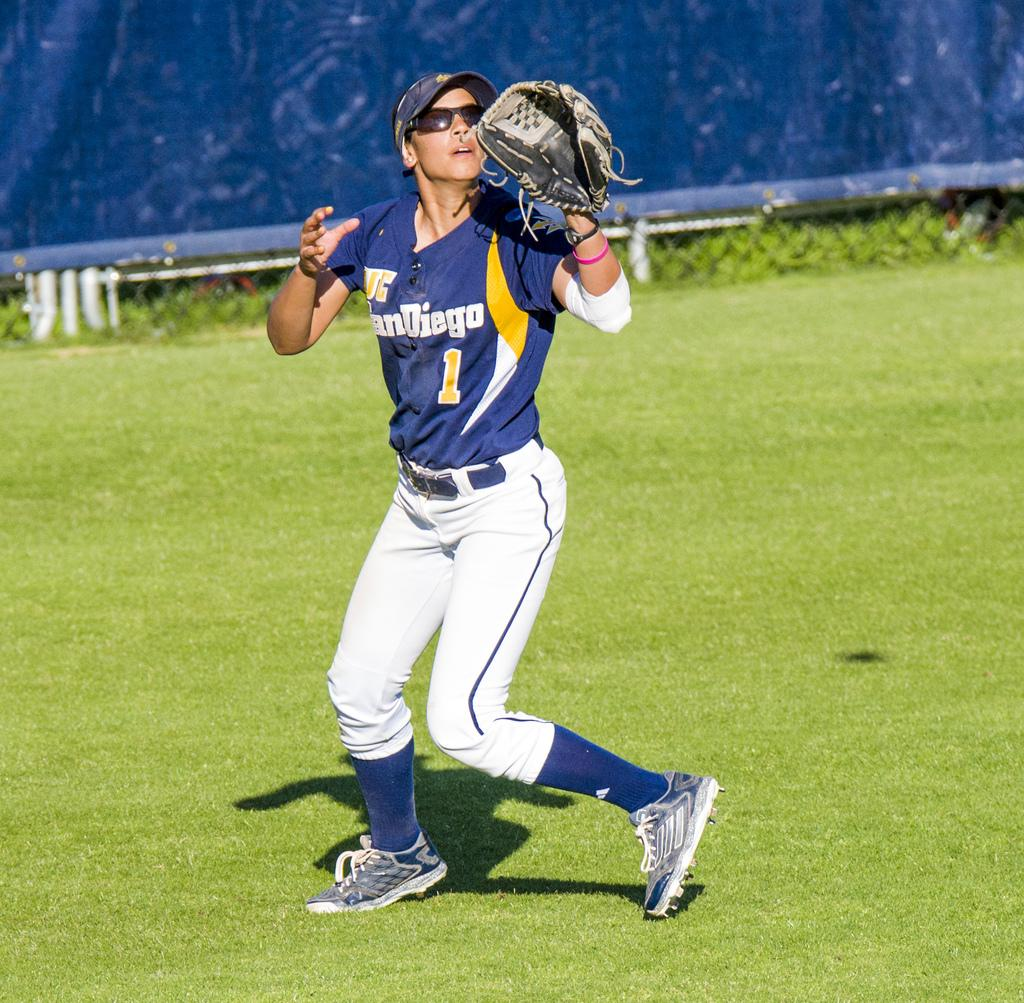<image>
Create a compact narrative representing the image presented. San Diego #1 baseball player about to catch a baseball. 